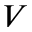Convert formula to latex. <formula><loc_0><loc_0><loc_500><loc_500>V</formula> 